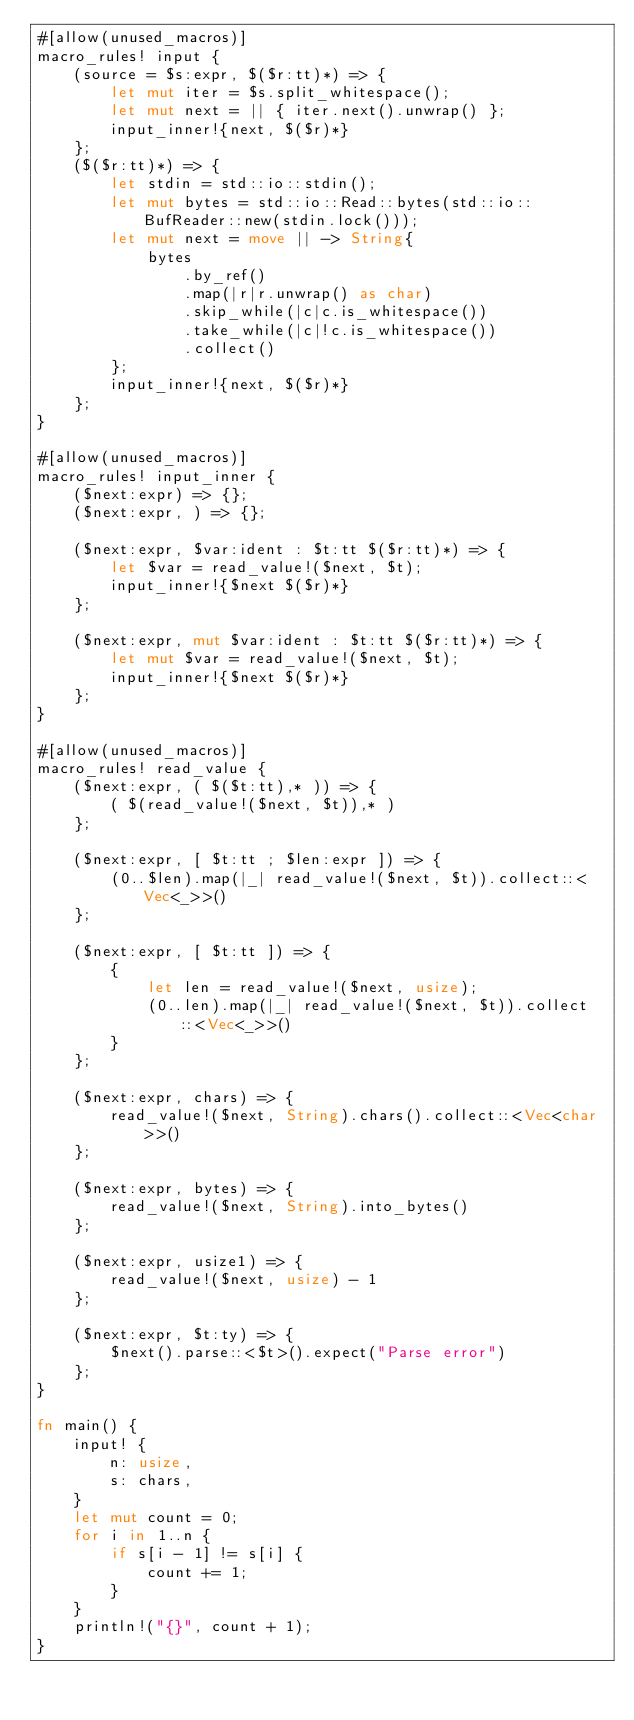Convert code to text. <code><loc_0><loc_0><loc_500><loc_500><_Rust_>#[allow(unused_macros)]
macro_rules! input {
    (source = $s:expr, $($r:tt)*) => {
        let mut iter = $s.split_whitespace();
        let mut next = || { iter.next().unwrap() };
        input_inner!{next, $($r)*}
    };
    ($($r:tt)*) => {
        let stdin = std::io::stdin();
        let mut bytes = std::io::Read::bytes(std::io::BufReader::new(stdin.lock()));
        let mut next = move || -> String{
            bytes
                .by_ref()
                .map(|r|r.unwrap() as char)
                .skip_while(|c|c.is_whitespace())
                .take_while(|c|!c.is_whitespace())
                .collect()
        };
        input_inner!{next, $($r)*}
    };
}

#[allow(unused_macros)]
macro_rules! input_inner {
    ($next:expr) => {};
    ($next:expr, ) => {};

    ($next:expr, $var:ident : $t:tt $($r:tt)*) => {
        let $var = read_value!($next, $t);
        input_inner!{$next $($r)*}
    };

    ($next:expr, mut $var:ident : $t:tt $($r:tt)*) => {
        let mut $var = read_value!($next, $t);
        input_inner!{$next $($r)*}
    };
}

#[allow(unused_macros)]
macro_rules! read_value {
    ($next:expr, ( $($t:tt),* )) => {
        ( $(read_value!($next, $t)),* )
    };

    ($next:expr, [ $t:tt ; $len:expr ]) => {
        (0..$len).map(|_| read_value!($next, $t)).collect::<Vec<_>>()
    };

    ($next:expr, [ $t:tt ]) => {
        {
            let len = read_value!($next, usize);
            (0..len).map(|_| read_value!($next, $t)).collect::<Vec<_>>()
        }
    };

    ($next:expr, chars) => {
        read_value!($next, String).chars().collect::<Vec<char>>()
    };

    ($next:expr, bytes) => {
        read_value!($next, String).into_bytes()
    };

    ($next:expr, usize1) => {
        read_value!($next, usize) - 1
    };

    ($next:expr, $t:ty) => {
        $next().parse::<$t>().expect("Parse error")
    };
}

fn main() {
    input! {
        n: usize,
        s: chars,
    }
    let mut count = 0;
    for i in 1..n {
        if s[i - 1] != s[i] {
            count += 1;
        }
    }
    println!("{}", count + 1);
}
</code> 